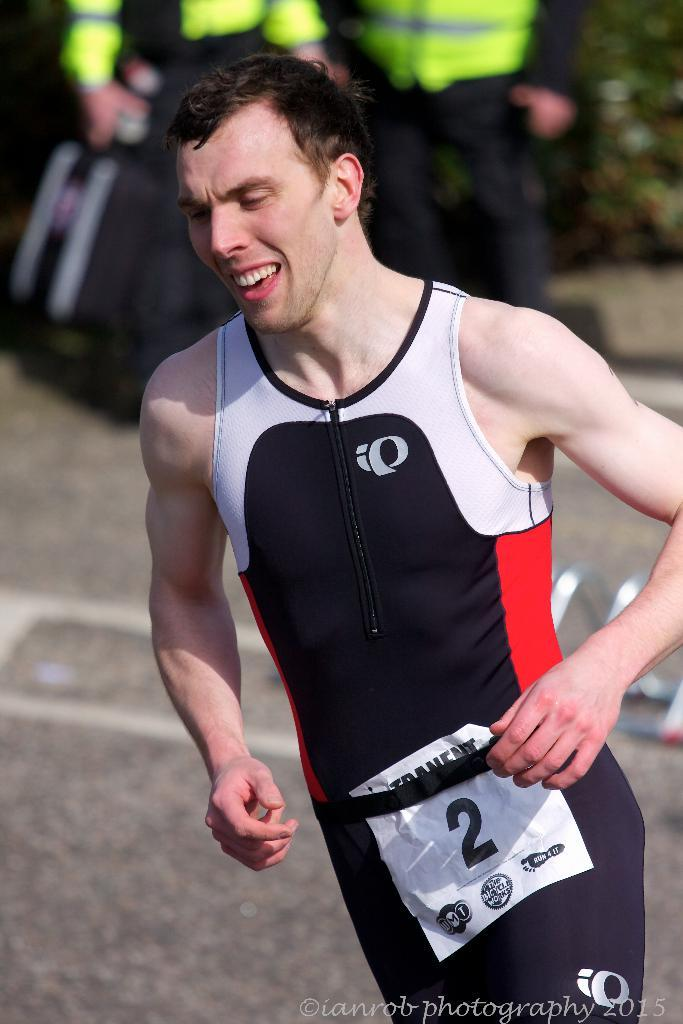<image>
Create a compact narrative representing the image presented. A man running a marathon in a black, white and red running suite with the number two and run and fit entry form on the front. 